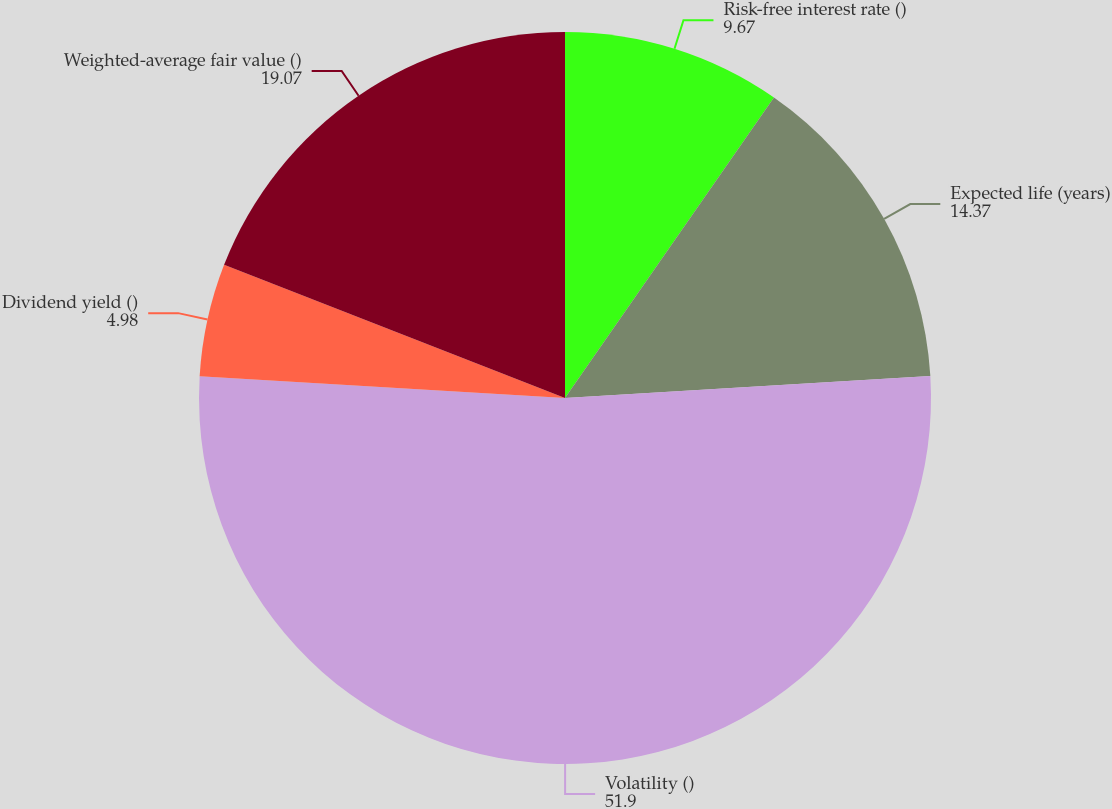Convert chart. <chart><loc_0><loc_0><loc_500><loc_500><pie_chart><fcel>Risk-free interest rate ()<fcel>Expected life (years)<fcel>Volatility ()<fcel>Dividend yield ()<fcel>Weighted-average fair value ()<nl><fcel>9.67%<fcel>14.37%<fcel>51.9%<fcel>4.98%<fcel>19.07%<nl></chart> 